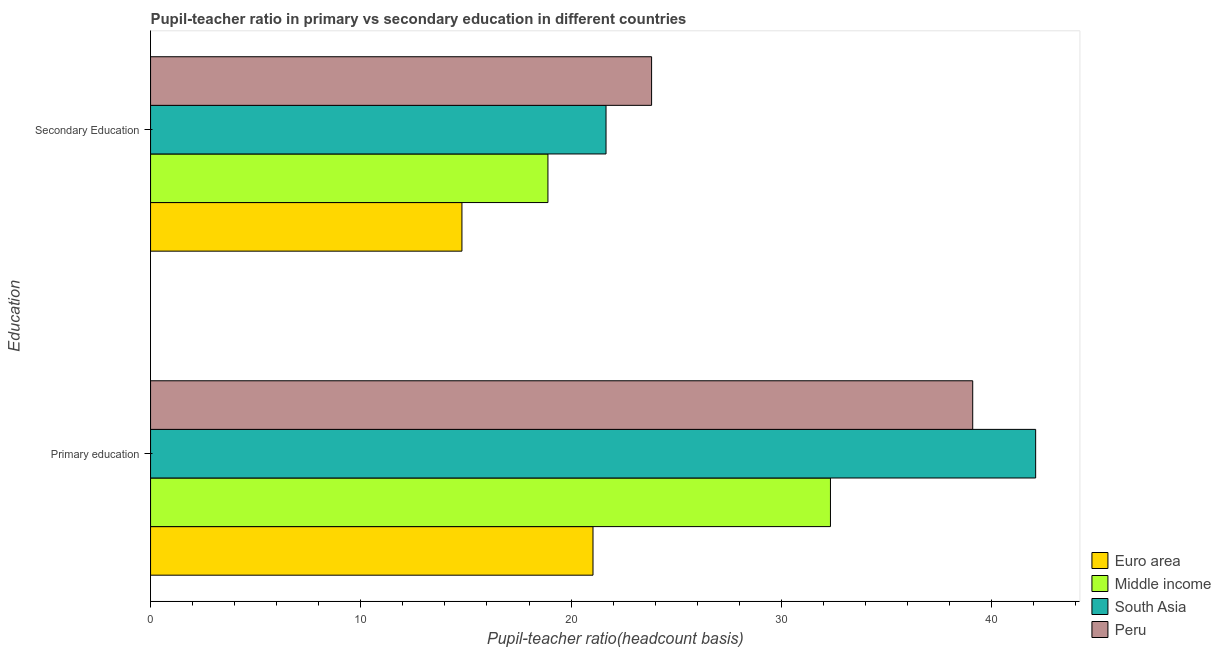How many groups of bars are there?
Provide a succinct answer. 2. Are the number of bars on each tick of the Y-axis equal?
Provide a succinct answer. Yes. How many bars are there on the 2nd tick from the bottom?
Provide a succinct answer. 4. What is the label of the 1st group of bars from the top?
Your response must be concise. Secondary Education. What is the pupil-teacher ratio in primary education in Euro area?
Your answer should be compact. 21.04. Across all countries, what is the maximum pupil teacher ratio on secondary education?
Your answer should be compact. 23.83. Across all countries, what is the minimum pupil-teacher ratio in primary education?
Provide a succinct answer. 21.04. In which country was the pupil teacher ratio on secondary education maximum?
Your response must be concise. Peru. What is the total pupil-teacher ratio in primary education in the graph?
Ensure brevity in your answer.  134.59. What is the difference between the pupil-teacher ratio in primary education in South Asia and that in Euro area?
Give a very brief answer. 21.05. What is the difference between the pupil-teacher ratio in primary education in Middle income and the pupil teacher ratio on secondary education in South Asia?
Provide a succinct answer. 10.67. What is the average pupil teacher ratio on secondary education per country?
Your answer should be compact. 19.8. What is the difference between the pupil-teacher ratio in primary education and pupil teacher ratio on secondary education in Peru?
Your answer should be very brief. 15.27. What is the ratio of the pupil teacher ratio on secondary education in South Asia to that in Middle income?
Make the answer very short. 1.15. Is the pupil teacher ratio on secondary education in Euro area less than that in Peru?
Provide a succinct answer. Yes. How many bars are there?
Ensure brevity in your answer.  8. Are all the bars in the graph horizontal?
Provide a succinct answer. Yes. How many countries are there in the graph?
Give a very brief answer. 4. Are the values on the major ticks of X-axis written in scientific E-notation?
Offer a terse response. No. Where does the legend appear in the graph?
Offer a terse response. Bottom right. What is the title of the graph?
Offer a very short reply. Pupil-teacher ratio in primary vs secondary education in different countries. What is the label or title of the X-axis?
Provide a short and direct response. Pupil-teacher ratio(headcount basis). What is the label or title of the Y-axis?
Provide a succinct answer. Education. What is the Pupil-teacher ratio(headcount basis) of Euro area in Primary education?
Provide a succinct answer. 21.04. What is the Pupil-teacher ratio(headcount basis) in Middle income in Primary education?
Your answer should be compact. 32.34. What is the Pupil-teacher ratio(headcount basis) of South Asia in Primary education?
Keep it short and to the point. 42.1. What is the Pupil-teacher ratio(headcount basis) in Peru in Primary education?
Offer a terse response. 39.1. What is the Pupil-teacher ratio(headcount basis) of Euro area in Secondary Education?
Give a very brief answer. 14.81. What is the Pupil-teacher ratio(headcount basis) in Middle income in Secondary Education?
Your response must be concise. 18.9. What is the Pupil-teacher ratio(headcount basis) in South Asia in Secondary Education?
Offer a very short reply. 21.66. What is the Pupil-teacher ratio(headcount basis) in Peru in Secondary Education?
Ensure brevity in your answer.  23.83. Across all Education, what is the maximum Pupil-teacher ratio(headcount basis) in Euro area?
Your answer should be very brief. 21.04. Across all Education, what is the maximum Pupil-teacher ratio(headcount basis) in Middle income?
Your answer should be very brief. 32.34. Across all Education, what is the maximum Pupil-teacher ratio(headcount basis) of South Asia?
Offer a terse response. 42.1. Across all Education, what is the maximum Pupil-teacher ratio(headcount basis) in Peru?
Keep it short and to the point. 39.1. Across all Education, what is the minimum Pupil-teacher ratio(headcount basis) of Euro area?
Offer a very short reply. 14.81. Across all Education, what is the minimum Pupil-teacher ratio(headcount basis) of Middle income?
Offer a very short reply. 18.9. Across all Education, what is the minimum Pupil-teacher ratio(headcount basis) of South Asia?
Offer a terse response. 21.66. Across all Education, what is the minimum Pupil-teacher ratio(headcount basis) of Peru?
Keep it short and to the point. 23.83. What is the total Pupil-teacher ratio(headcount basis) of Euro area in the graph?
Your response must be concise. 35.85. What is the total Pupil-teacher ratio(headcount basis) in Middle income in the graph?
Keep it short and to the point. 51.24. What is the total Pupil-teacher ratio(headcount basis) of South Asia in the graph?
Make the answer very short. 63.76. What is the total Pupil-teacher ratio(headcount basis) in Peru in the graph?
Your response must be concise. 62.94. What is the difference between the Pupil-teacher ratio(headcount basis) in Euro area in Primary education and that in Secondary Education?
Offer a very short reply. 6.23. What is the difference between the Pupil-teacher ratio(headcount basis) in Middle income in Primary education and that in Secondary Education?
Your answer should be very brief. 13.44. What is the difference between the Pupil-teacher ratio(headcount basis) in South Asia in Primary education and that in Secondary Education?
Your answer should be compact. 20.44. What is the difference between the Pupil-teacher ratio(headcount basis) of Peru in Primary education and that in Secondary Education?
Offer a terse response. 15.27. What is the difference between the Pupil-teacher ratio(headcount basis) of Euro area in Primary education and the Pupil-teacher ratio(headcount basis) of Middle income in Secondary Education?
Make the answer very short. 2.14. What is the difference between the Pupil-teacher ratio(headcount basis) of Euro area in Primary education and the Pupil-teacher ratio(headcount basis) of South Asia in Secondary Education?
Give a very brief answer. -0.62. What is the difference between the Pupil-teacher ratio(headcount basis) of Euro area in Primary education and the Pupil-teacher ratio(headcount basis) of Peru in Secondary Education?
Your response must be concise. -2.79. What is the difference between the Pupil-teacher ratio(headcount basis) in Middle income in Primary education and the Pupil-teacher ratio(headcount basis) in South Asia in Secondary Education?
Ensure brevity in your answer.  10.67. What is the difference between the Pupil-teacher ratio(headcount basis) of Middle income in Primary education and the Pupil-teacher ratio(headcount basis) of Peru in Secondary Education?
Ensure brevity in your answer.  8.51. What is the difference between the Pupil-teacher ratio(headcount basis) in South Asia in Primary education and the Pupil-teacher ratio(headcount basis) in Peru in Secondary Education?
Your answer should be compact. 18.27. What is the average Pupil-teacher ratio(headcount basis) of Euro area per Education?
Offer a very short reply. 17.93. What is the average Pupil-teacher ratio(headcount basis) of Middle income per Education?
Offer a very short reply. 25.62. What is the average Pupil-teacher ratio(headcount basis) in South Asia per Education?
Provide a succinct answer. 31.88. What is the average Pupil-teacher ratio(headcount basis) in Peru per Education?
Offer a terse response. 31.47. What is the difference between the Pupil-teacher ratio(headcount basis) in Euro area and Pupil-teacher ratio(headcount basis) in Middle income in Primary education?
Offer a terse response. -11.29. What is the difference between the Pupil-teacher ratio(headcount basis) of Euro area and Pupil-teacher ratio(headcount basis) of South Asia in Primary education?
Offer a very short reply. -21.05. What is the difference between the Pupil-teacher ratio(headcount basis) of Euro area and Pupil-teacher ratio(headcount basis) of Peru in Primary education?
Your answer should be compact. -18.06. What is the difference between the Pupil-teacher ratio(headcount basis) of Middle income and Pupil-teacher ratio(headcount basis) of South Asia in Primary education?
Provide a short and direct response. -9.76. What is the difference between the Pupil-teacher ratio(headcount basis) in Middle income and Pupil-teacher ratio(headcount basis) in Peru in Primary education?
Offer a very short reply. -6.77. What is the difference between the Pupil-teacher ratio(headcount basis) of South Asia and Pupil-teacher ratio(headcount basis) of Peru in Primary education?
Your answer should be very brief. 2.99. What is the difference between the Pupil-teacher ratio(headcount basis) of Euro area and Pupil-teacher ratio(headcount basis) of Middle income in Secondary Education?
Offer a terse response. -4.09. What is the difference between the Pupil-teacher ratio(headcount basis) of Euro area and Pupil-teacher ratio(headcount basis) of South Asia in Secondary Education?
Give a very brief answer. -6.85. What is the difference between the Pupil-teacher ratio(headcount basis) of Euro area and Pupil-teacher ratio(headcount basis) of Peru in Secondary Education?
Offer a terse response. -9.02. What is the difference between the Pupil-teacher ratio(headcount basis) in Middle income and Pupil-teacher ratio(headcount basis) in South Asia in Secondary Education?
Ensure brevity in your answer.  -2.76. What is the difference between the Pupil-teacher ratio(headcount basis) in Middle income and Pupil-teacher ratio(headcount basis) in Peru in Secondary Education?
Your answer should be compact. -4.93. What is the difference between the Pupil-teacher ratio(headcount basis) in South Asia and Pupil-teacher ratio(headcount basis) in Peru in Secondary Education?
Your answer should be very brief. -2.17. What is the ratio of the Pupil-teacher ratio(headcount basis) in Euro area in Primary education to that in Secondary Education?
Provide a short and direct response. 1.42. What is the ratio of the Pupil-teacher ratio(headcount basis) in Middle income in Primary education to that in Secondary Education?
Provide a short and direct response. 1.71. What is the ratio of the Pupil-teacher ratio(headcount basis) in South Asia in Primary education to that in Secondary Education?
Make the answer very short. 1.94. What is the ratio of the Pupil-teacher ratio(headcount basis) in Peru in Primary education to that in Secondary Education?
Provide a succinct answer. 1.64. What is the difference between the highest and the second highest Pupil-teacher ratio(headcount basis) of Euro area?
Offer a terse response. 6.23. What is the difference between the highest and the second highest Pupil-teacher ratio(headcount basis) of Middle income?
Give a very brief answer. 13.44. What is the difference between the highest and the second highest Pupil-teacher ratio(headcount basis) in South Asia?
Ensure brevity in your answer.  20.44. What is the difference between the highest and the second highest Pupil-teacher ratio(headcount basis) in Peru?
Give a very brief answer. 15.27. What is the difference between the highest and the lowest Pupil-teacher ratio(headcount basis) in Euro area?
Give a very brief answer. 6.23. What is the difference between the highest and the lowest Pupil-teacher ratio(headcount basis) in Middle income?
Offer a terse response. 13.44. What is the difference between the highest and the lowest Pupil-teacher ratio(headcount basis) of South Asia?
Give a very brief answer. 20.44. What is the difference between the highest and the lowest Pupil-teacher ratio(headcount basis) in Peru?
Your response must be concise. 15.27. 